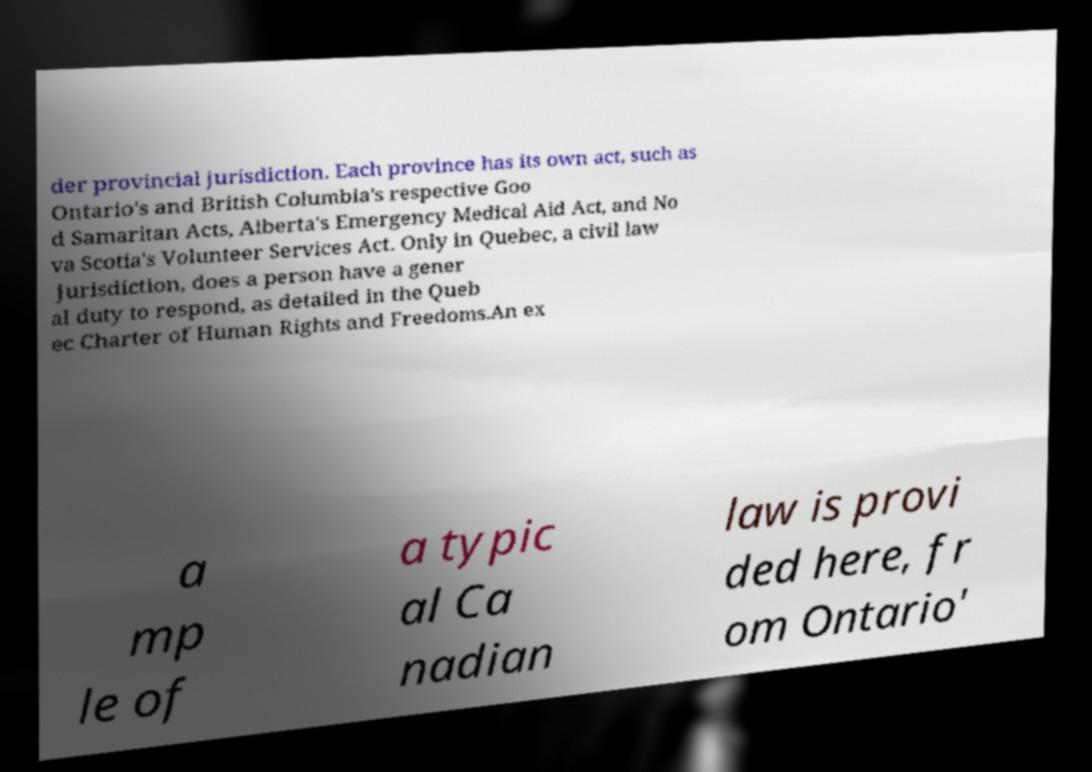Could you extract and type out the text from this image? der provincial jurisdiction. Each province has its own act, such as Ontario's and British Columbia's respective Goo d Samaritan Acts, Alberta's Emergency Medical Aid Act, and No va Scotia's Volunteer Services Act. Only in Quebec, a civil law jurisdiction, does a person have a gener al duty to respond, as detailed in the Queb ec Charter of Human Rights and Freedoms.An ex a mp le of a typic al Ca nadian law is provi ded here, fr om Ontario' 